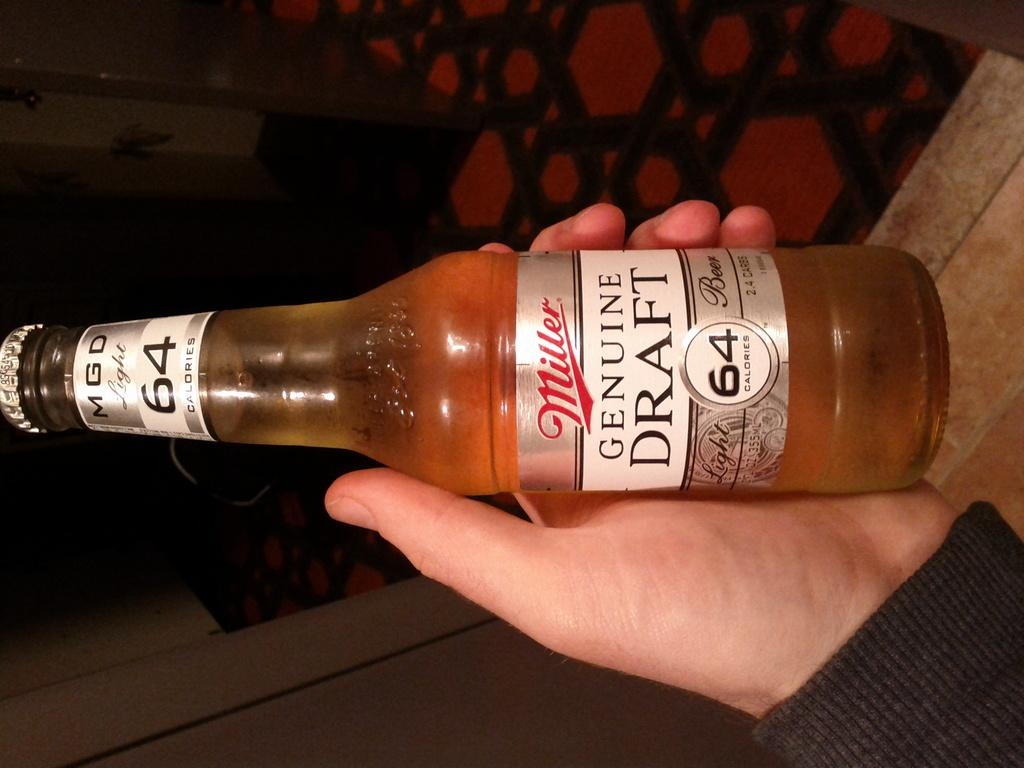What is the main object in the image? There is a wine bottle in the image. How is the wine bottle being held? The wine bottle is being held in a hand. What is the name of the wine bottle? The name of the wine bottle is "genuine draft." Can you tell me how many basketballs are on the page next to the wine bottle? There are no basketballs or pages present in the image; it only features a wine bottle being held in a hand. 